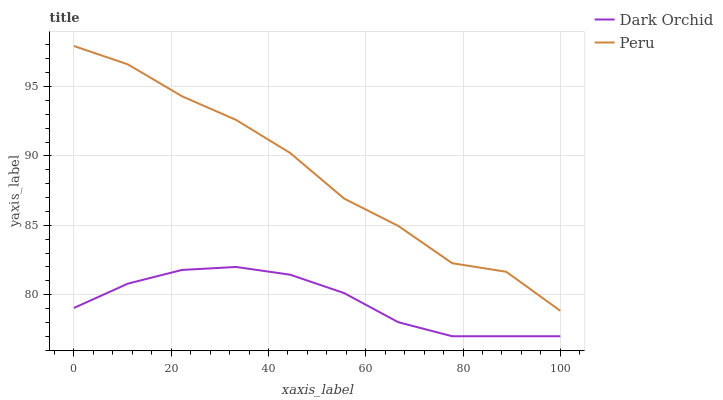Does Dark Orchid have the minimum area under the curve?
Answer yes or no. Yes. Does Peru have the maximum area under the curve?
Answer yes or no. Yes. Does Dark Orchid have the maximum area under the curve?
Answer yes or no. No. Is Dark Orchid the smoothest?
Answer yes or no. Yes. Is Peru the roughest?
Answer yes or no. Yes. Is Dark Orchid the roughest?
Answer yes or no. No. Does Dark Orchid have the lowest value?
Answer yes or no. Yes. Does Peru have the highest value?
Answer yes or no. Yes. Does Dark Orchid have the highest value?
Answer yes or no. No. Is Dark Orchid less than Peru?
Answer yes or no. Yes. Is Peru greater than Dark Orchid?
Answer yes or no. Yes. Does Dark Orchid intersect Peru?
Answer yes or no. No. 